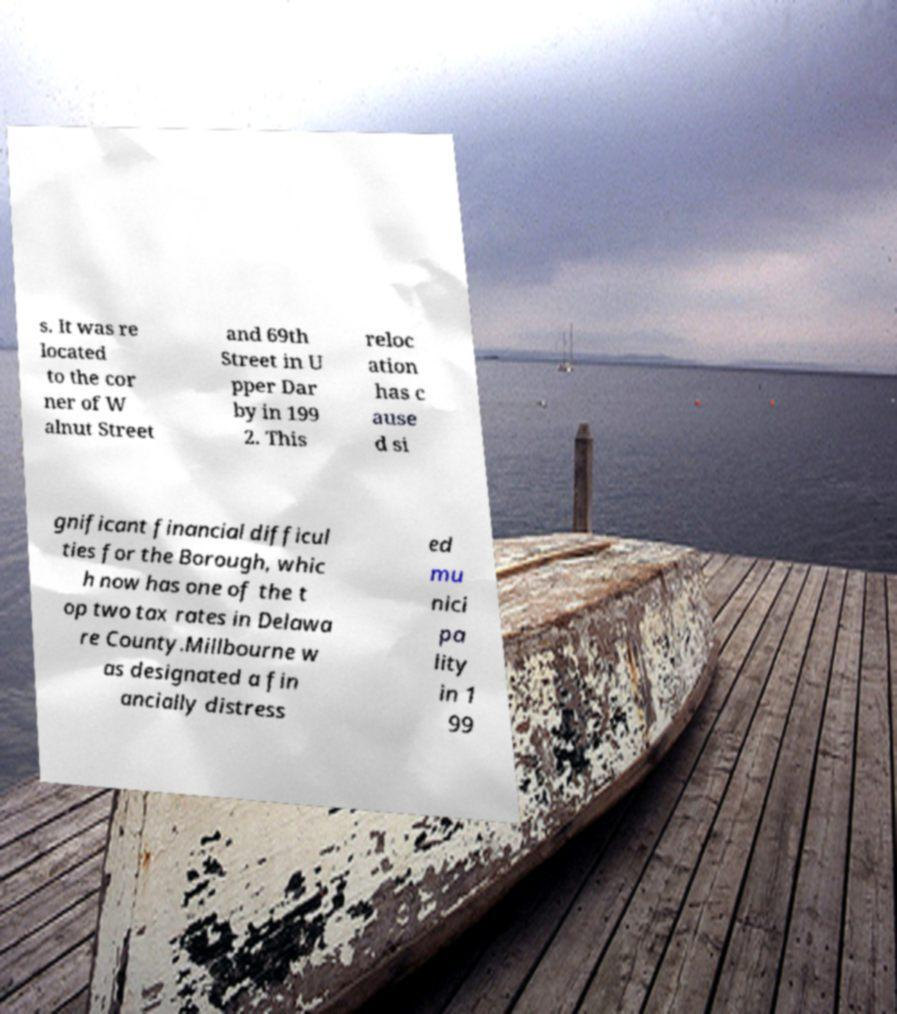Please identify and transcribe the text found in this image. s. It was re located to the cor ner of W alnut Street and 69th Street in U pper Dar by in 199 2. This reloc ation has c ause d si gnificant financial difficul ties for the Borough, whic h now has one of the t op two tax rates in Delawa re County.Millbourne w as designated a fin ancially distress ed mu nici pa lity in 1 99 